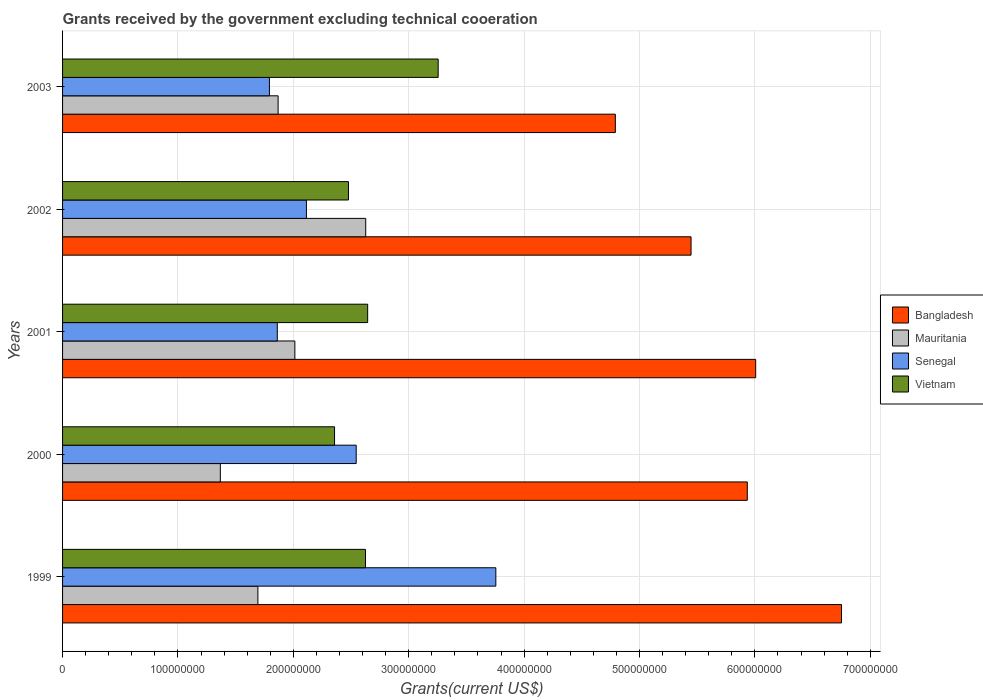How many different coloured bars are there?
Your answer should be compact. 4. How many groups of bars are there?
Give a very brief answer. 5. Are the number of bars per tick equal to the number of legend labels?
Your response must be concise. Yes. Are the number of bars on each tick of the Y-axis equal?
Your answer should be very brief. Yes. How many bars are there on the 4th tick from the top?
Your answer should be very brief. 4. What is the label of the 4th group of bars from the top?
Keep it short and to the point. 2000. In how many cases, is the number of bars for a given year not equal to the number of legend labels?
Give a very brief answer. 0. What is the total grants received by the government in Vietnam in 2002?
Your response must be concise. 2.48e+08. Across all years, what is the maximum total grants received by the government in Mauritania?
Keep it short and to the point. 2.63e+08. Across all years, what is the minimum total grants received by the government in Mauritania?
Your answer should be compact. 1.37e+08. In which year was the total grants received by the government in Senegal maximum?
Give a very brief answer. 1999. What is the total total grants received by the government in Bangladesh in the graph?
Make the answer very short. 2.89e+09. What is the difference between the total grants received by the government in Mauritania in 1999 and that in 2000?
Offer a terse response. 3.26e+07. What is the difference between the total grants received by the government in Mauritania in 2000 and the total grants received by the government in Bangladesh in 2001?
Your answer should be very brief. -4.64e+08. What is the average total grants received by the government in Vietnam per year?
Your response must be concise. 2.67e+08. In the year 2001, what is the difference between the total grants received by the government in Senegal and total grants received by the government in Bangladesh?
Provide a succinct answer. -4.15e+08. What is the ratio of the total grants received by the government in Vietnam in 2000 to that in 2003?
Make the answer very short. 0.72. Is the difference between the total grants received by the government in Senegal in 2000 and 2001 greater than the difference between the total grants received by the government in Bangladesh in 2000 and 2001?
Make the answer very short. Yes. What is the difference between the highest and the second highest total grants received by the government in Mauritania?
Make the answer very short. 6.14e+07. What is the difference between the highest and the lowest total grants received by the government in Bangladesh?
Give a very brief answer. 1.96e+08. Is it the case that in every year, the sum of the total grants received by the government in Mauritania and total grants received by the government in Bangladesh is greater than the sum of total grants received by the government in Senegal and total grants received by the government in Vietnam?
Offer a terse response. No. What does the 3rd bar from the top in 2000 represents?
Offer a very short reply. Mauritania. What does the 4th bar from the bottom in 2000 represents?
Provide a short and direct response. Vietnam. Is it the case that in every year, the sum of the total grants received by the government in Bangladesh and total grants received by the government in Vietnam is greater than the total grants received by the government in Mauritania?
Offer a terse response. Yes. Are all the bars in the graph horizontal?
Your answer should be compact. Yes. What is the difference between two consecutive major ticks on the X-axis?
Your response must be concise. 1.00e+08. Does the graph contain grids?
Offer a terse response. Yes. Where does the legend appear in the graph?
Offer a very short reply. Center right. What is the title of the graph?
Your answer should be compact. Grants received by the government excluding technical cooeration. What is the label or title of the X-axis?
Your answer should be very brief. Grants(current US$). What is the label or title of the Y-axis?
Your answer should be very brief. Years. What is the Grants(current US$) of Bangladesh in 1999?
Your answer should be compact. 6.75e+08. What is the Grants(current US$) of Mauritania in 1999?
Give a very brief answer. 1.69e+08. What is the Grants(current US$) of Senegal in 1999?
Ensure brevity in your answer.  3.76e+08. What is the Grants(current US$) in Vietnam in 1999?
Provide a short and direct response. 2.63e+08. What is the Grants(current US$) of Bangladesh in 2000?
Ensure brevity in your answer.  5.93e+08. What is the Grants(current US$) of Mauritania in 2000?
Offer a terse response. 1.37e+08. What is the Grants(current US$) in Senegal in 2000?
Your answer should be compact. 2.54e+08. What is the Grants(current US$) in Vietnam in 2000?
Make the answer very short. 2.36e+08. What is the Grants(current US$) in Bangladesh in 2001?
Your answer should be compact. 6.01e+08. What is the Grants(current US$) in Mauritania in 2001?
Give a very brief answer. 2.01e+08. What is the Grants(current US$) of Senegal in 2001?
Provide a succinct answer. 1.86e+08. What is the Grants(current US$) in Vietnam in 2001?
Your response must be concise. 2.64e+08. What is the Grants(current US$) in Bangladesh in 2002?
Your answer should be compact. 5.45e+08. What is the Grants(current US$) in Mauritania in 2002?
Make the answer very short. 2.63e+08. What is the Grants(current US$) in Senegal in 2002?
Your answer should be compact. 2.11e+08. What is the Grants(current US$) in Vietnam in 2002?
Offer a very short reply. 2.48e+08. What is the Grants(current US$) of Bangladesh in 2003?
Keep it short and to the point. 4.79e+08. What is the Grants(current US$) of Mauritania in 2003?
Provide a short and direct response. 1.87e+08. What is the Grants(current US$) in Senegal in 2003?
Make the answer very short. 1.79e+08. What is the Grants(current US$) of Vietnam in 2003?
Provide a short and direct response. 3.26e+08. Across all years, what is the maximum Grants(current US$) of Bangladesh?
Offer a terse response. 6.75e+08. Across all years, what is the maximum Grants(current US$) of Mauritania?
Ensure brevity in your answer.  2.63e+08. Across all years, what is the maximum Grants(current US$) of Senegal?
Provide a succinct answer. 3.76e+08. Across all years, what is the maximum Grants(current US$) in Vietnam?
Give a very brief answer. 3.26e+08. Across all years, what is the minimum Grants(current US$) of Bangladesh?
Keep it short and to the point. 4.79e+08. Across all years, what is the minimum Grants(current US$) in Mauritania?
Your response must be concise. 1.37e+08. Across all years, what is the minimum Grants(current US$) of Senegal?
Give a very brief answer. 1.79e+08. Across all years, what is the minimum Grants(current US$) in Vietnam?
Keep it short and to the point. 2.36e+08. What is the total Grants(current US$) in Bangladesh in the graph?
Give a very brief answer. 2.89e+09. What is the total Grants(current US$) in Mauritania in the graph?
Offer a very short reply. 9.57e+08. What is the total Grants(current US$) of Senegal in the graph?
Provide a succinct answer. 1.21e+09. What is the total Grants(current US$) of Vietnam in the graph?
Provide a succinct answer. 1.34e+09. What is the difference between the Grants(current US$) in Bangladesh in 1999 and that in 2000?
Provide a succinct answer. 8.17e+07. What is the difference between the Grants(current US$) of Mauritania in 1999 and that in 2000?
Ensure brevity in your answer.  3.26e+07. What is the difference between the Grants(current US$) of Senegal in 1999 and that in 2000?
Give a very brief answer. 1.21e+08. What is the difference between the Grants(current US$) of Vietnam in 1999 and that in 2000?
Offer a terse response. 2.68e+07. What is the difference between the Grants(current US$) of Bangladesh in 1999 and that in 2001?
Offer a terse response. 7.44e+07. What is the difference between the Grants(current US$) in Mauritania in 1999 and that in 2001?
Keep it short and to the point. -3.20e+07. What is the difference between the Grants(current US$) in Senegal in 1999 and that in 2001?
Offer a very short reply. 1.89e+08. What is the difference between the Grants(current US$) in Vietnam in 1999 and that in 2001?
Your response must be concise. -1.88e+06. What is the difference between the Grants(current US$) of Bangladesh in 1999 and that in 2002?
Make the answer very short. 1.30e+08. What is the difference between the Grants(current US$) in Mauritania in 1999 and that in 2002?
Your answer should be compact. -9.34e+07. What is the difference between the Grants(current US$) in Senegal in 1999 and that in 2002?
Give a very brief answer. 1.64e+08. What is the difference between the Grants(current US$) in Vietnam in 1999 and that in 2002?
Offer a very short reply. 1.48e+07. What is the difference between the Grants(current US$) of Bangladesh in 1999 and that in 2003?
Your answer should be very brief. 1.96e+08. What is the difference between the Grants(current US$) in Mauritania in 1999 and that in 2003?
Offer a terse response. -1.75e+07. What is the difference between the Grants(current US$) in Senegal in 1999 and that in 2003?
Your answer should be very brief. 1.96e+08. What is the difference between the Grants(current US$) in Vietnam in 1999 and that in 2003?
Provide a short and direct response. -6.30e+07. What is the difference between the Grants(current US$) in Bangladesh in 2000 and that in 2001?
Your answer should be compact. -7.28e+06. What is the difference between the Grants(current US$) in Mauritania in 2000 and that in 2001?
Your response must be concise. -6.46e+07. What is the difference between the Grants(current US$) of Senegal in 2000 and that in 2001?
Your answer should be very brief. 6.84e+07. What is the difference between the Grants(current US$) of Vietnam in 2000 and that in 2001?
Offer a very short reply. -2.87e+07. What is the difference between the Grants(current US$) in Bangladesh in 2000 and that in 2002?
Your response must be concise. 4.88e+07. What is the difference between the Grants(current US$) in Mauritania in 2000 and that in 2002?
Give a very brief answer. -1.26e+08. What is the difference between the Grants(current US$) in Senegal in 2000 and that in 2002?
Your answer should be compact. 4.31e+07. What is the difference between the Grants(current US$) of Vietnam in 2000 and that in 2002?
Ensure brevity in your answer.  -1.21e+07. What is the difference between the Grants(current US$) of Bangladesh in 2000 and that in 2003?
Ensure brevity in your answer.  1.14e+08. What is the difference between the Grants(current US$) of Mauritania in 2000 and that in 2003?
Your answer should be very brief. -5.01e+07. What is the difference between the Grants(current US$) in Senegal in 2000 and that in 2003?
Your response must be concise. 7.52e+07. What is the difference between the Grants(current US$) in Vietnam in 2000 and that in 2003?
Your answer should be compact. -8.98e+07. What is the difference between the Grants(current US$) in Bangladesh in 2001 and that in 2002?
Make the answer very short. 5.60e+07. What is the difference between the Grants(current US$) in Mauritania in 2001 and that in 2002?
Your response must be concise. -6.14e+07. What is the difference between the Grants(current US$) in Senegal in 2001 and that in 2002?
Offer a terse response. -2.52e+07. What is the difference between the Grants(current US$) in Vietnam in 2001 and that in 2002?
Ensure brevity in your answer.  1.66e+07. What is the difference between the Grants(current US$) of Bangladesh in 2001 and that in 2003?
Make the answer very short. 1.22e+08. What is the difference between the Grants(current US$) in Mauritania in 2001 and that in 2003?
Your answer should be very brief. 1.45e+07. What is the difference between the Grants(current US$) of Senegal in 2001 and that in 2003?
Provide a succinct answer. 6.82e+06. What is the difference between the Grants(current US$) of Vietnam in 2001 and that in 2003?
Your answer should be very brief. -6.11e+07. What is the difference between the Grants(current US$) in Bangladesh in 2002 and that in 2003?
Your response must be concise. 6.56e+07. What is the difference between the Grants(current US$) of Mauritania in 2002 and that in 2003?
Your answer should be compact. 7.59e+07. What is the difference between the Grants(current US$) in Senegal in 2002 and that in 2003?
Give a very brief answer. 3.21e+07. What is the difference between the Grants(current US$) of Vietnam in 2002 and that in 2003?
Keep it short and to the point. -7.77e+07. What is the difference between the Grants(current US$) of Bangladesh in 1999 and the Grants(current US$) of Mauritania in 2000?
Keep it short and to the point. 5.38e+08. What is the difference between the Grants(current US$) of Bangladesh in 1999 and the Grants(current US$) of Senegal in 2000?
Your answer should be compact. 4.21e+08. What is the difference between the Grants(current US$) of Bangladesh in 1999 and the Grants(current US$) of Vietnam in 2000?
Your response must be concise. 4.39e+08. What is the difference between the Grants(current US$) in Mauritania in 1999 and the Grants(current US$) in Senegal in 2000?
Your answer should be very brief. -8.52e+07. What is the difference between the Grants(current US$) in Mauritania in 1999 and the Grants(current US$) in Vietnam in 2000?
Your response must be concise. -6.64e+07. What is the difference between the Grants(current US$) in Senegal in 1999 and the Grants(current US$) in Vietnam in 2000?
Offer a terse response. 1.40e+08. What is the difference between the Grants(current US$) of Bangladesh in 1999 and the Grants(current US$) of Mauritania in 2001?
Offer a terse response. 4.74e+08. What is the difference between the Grants(current US$) of Bangladesh in 1999 and the Grants(current US$) of Senegal in 2001?
Your answer should be compact. 4.89e+08. What is the difference between the Grants(current US$) of Bangladesh in 1999 and the Grants(current US$) of Vietnam in 2001?
Provide a succinct answer. 4.11e+08. What is the difference between the Grants(current US$) in Mauritania in 1999 and the Grants(current US$) in Senegal in 2001?
Ensure brevity in your answer.  -1.68e+07. What is the difference between the Grants(current US$) of Mauritania in 1999 and the Grants(current US$) of Vietnam in 2001?
Make the answer very short. -9.51e+07. What is the difference between the Grants(current US$) of Senegal in 1999 and the Grants(current US$) of Vietnam in 2001?
Keep it short and to the point. 1.11e+08. What is the difference between the Grants(current US$) in Bangladesh in 1999 and the Grants(current US$) in Mauritania in 2002?
Provide a short and direct response. 4.12e+08. What is the difference between the Grants(current US$) in Bangladesh in 1999 and the Grants(current US$) in Senegal in 2002?
Offer a terse response. 4.64e+08. What is the difference between the Grants(current US$) in Bangladesh in 1999 and the Grants(current US$) in Vietnam in 2002?
Provide a succinct answer. 4.27e+08. What is the difference between the Grants(current US$) of Mauritania in 1999 and the Grants(current US$) of Senegal in 2002?
Your answer should be very brief. -4.21e+07. What is the difference between the Grants(current US$) of Mauritania in 1999 and the Grants(current US$) of Vietnam in 2002?
Give a very brief answer. -7.85e+07. What is the difference between the Grants(current US$) in Senegal in 1999 and the Grants(current US$) in Vietnam in 2002?
Your answer should be compact. 1.28e+08. What is the difference between the Grants(current US$) of Bangladesh in 1999 and the Grants(current US$) of Mauritania in 2003?
Give a very brief answer. 4.88e+08. What is the difference between the Grants(current US$) in Bangladesh in 1999 and the Grants(current US$) in Senegal in 2003?
Make the answer very short. 4.96e+08. What is the difference between the Grants(current US$) in Bangladesh in 1999 and the Grants(current US$) in Vietnam in 2003?
Give a very brief answer. 3.50e+08. What is the difference between the Grants(current US$) of Mauritania in 1999 and the Grants(current US$) of Senegal in 2003?
Provide a short and direct response. -1.00e+07. What is the difference between the Grants(current US$) in Mauritania in 1999 and the Grants(current US$) in Vietnam in 2003?
Keep it short and to the point. -1.56e+08. What is the difference between the Grants(current US$) of Senegal in 1999 and the Grants(current US$) of Vietnam in 2003?
Ensure brevity in your answer.  5.00e+07. What is the difference between the Grants(current US$) in Bangladesh in 2000 and the Grants(current US$) in Mauritania in 2001?
Your response must be concise. 3.92e+08. What is the difference between the Grants(current US$) of Bangladesh in 2000 and the Grants(current US$) of Senegal in 2001?
Your answer should be very brief. 4.07e+08. What is the difference between the Grants(current US$) of Bangladesh in 2000 and the Grants(current US$) of Vietnam in 2001?
Ensure brevity in your answer.  3.29e+08. What is the difference between the Grants(current US$) of Mauritania in 2000 and the Grants(current US$) of Senegal in 2001?
Give a very brief answer. -4.94e+07. What is the difference between the Grants(current US$) of Mauritania in 2000 and the Grants(current US$) of Vietnam in 2001?
Your answer should be compact. -1.28e+08. What is the difference between the Grants(current US$) in Senegal in 2000 and the Grants(current US$) in Vietnam in 2001?
Your response must be concise. -9.93e+06. What is the difference between the Grants(current US$) in Bangladesh in 2000 and the Grants(current US$) in Mauritania in 2002?
Make the answer very short. 3.31e+08. What is the difference between the Grants(current US$) of Bangladesh in 2000 and the Grants(current US$) of Senegal in 2002?
Keep it short and to the point. 3.82e+08. What is the difference between the Grants(current US$) in Bangladesh in 2000 and the Grants(current US$) in Vietnam in 2002?
Your answer should be very brief. 3.46e+08. What is the difference between the Grants(current US$) of Mauritania in 2000 and the Grants(current US$) of Senegal in 2002?
Your response must be concise. -7.46e+07. What is the difference between the Grants(current US$) in Mauritania in 2000 and the Grants(current US$) in Vietnam in 2002?
Keep it short and to the point. -1.11e+08. What is the difference between the Grants(current US$) in Senegal in 2000 and the Grants(current US$) in Vietnam in 2002?
Offer a very short reply. 6.70e+06. What is the difference between the Grants(current US$) in Bangladesh in 2000 and the Grants(current US$) in Mauritania in 2003?
Make the answer very short. 4.07e+08. What is the difference between the Grants(current US$) in Bangladesh in 2000 and the Grants(current US$) in Senegal in 2003?
Offer a very short reply. 4.14e+08. What is the difference between the Grants(current US$) in Bangladesh in 2000 and the Grants(current US$) in Vietnam in 2003?
Make the answer very short. 2.68e+08. What is the difference between the Grants(current US$) in Mauritania in 2000 and the Grants(current US$) in Senegal in 2003?
Your answer should be compact. -4.26e+07. What is the difference between the Grants(current US$) of Mauritania in 2000 and the Grants(current US$) of Vietnam in 2003?
Your answer should be compact. -1.89e+08. What is the difference between the Grants(current US$) in Senegal in 2000 and the Grants(current US$) in Vietnam in 2003?
Your response must be concise. -7.10e+07. What is the difference between the Grants(current US$) of Bangladesh in 2001 and the Grants(current US$) of Mauritania in 2002?
Your answer should be compact. 3.38e+08. What is the difference between the Grants(current US$) of Bangladesh in 2001 and the Grants(current US$) of Senegal in 2002?
Your response must be concise. 3.89e+08. What is the difference between the Grants(current US$) in Bangladesh in 2001 and the Grants(current US$) in Vietnam in 2002?
Your answer should be very brief. 3.53e+08. What is the difference between the Grants(current US$) in Mauritania in 2001 and the Grants(current US$) in Senegal in 2002?
Your response must be concise. -1.00e+07. What is the difference between the Grants(current US$) in Mauritania in 2001 and the Grants(current US$) in Vietnam in 2002?
Offer a terse response. -4.65e+07. What is the difference between the Grants(current US$) of Senegal in 2001 and the Grants(current US$) of Vietnam in 2002?
Give a very brief answer. -6.17e+07. What is the difference between the Grants(current US$) in Bangladesh in 2001 and the Grants(current US$) in Mauritania in 2003?
Your response must be concise. 4.14e+08. What is the difference between the Grants(current US$) in Bangladesh in 2001 and the Grants(current US$) in Senegal in 2003?
Offer a very short reply. 4.21e+08. What is the difference between the Grants(current US$) in Bangladesh in 2001 and the Grants(current US$) in Vietnam in 2003?
Keep it short and to the point. 2.75e+08. What is the difference between the Grants(current US$) in Mauritania in 2001 and the Grants(current US$) in Senegal in 2003?
Make the answer very short. 2.20e+07. What is the difference between the Grants(current US$) of Mauritania in 2001 and the Grants(current US$) of Vietnam in 2003?
Give a very brief answer. -1.24e+08. What is the difference between the Grants(current US$) of Senegal in 2001 and the Grants(current US$) of Vietnam in 2003?
Give a very brief answer. -1.39e+08. What is the difference between the Grants(current US$) in Bangladesh in 2002 and the Grants(current US$) in Mauritania in 2003?
Your answer should be very brief. 3.58e+08. What is the difference between the Grants(current US$) in Bangladesh in 2002 and the Grants(current US$) in Senegal in 2003?
Provide a short and direct response. 3.65e+08. What is the difference between the Grants(current US$) in Bangladesh in 2002 and the Grants(current US$) in Vietnam in 2003?
Provide a short and direct response. 2.19e+08. What is the difference between the Grants(current US$) of Mauritania in 2002 and the Grants(current US$) of Senegal in 2003?
Offer a terse response. 8.34e+07. What is the difference between the Grants(current US$) in Mauritania in 2002 and the Grants(current US$) in Vietnam in 2003?
Your answer should be very brief. -6.28e+07. What is the difference between the Grants(current US$) of Senegal in 2002 and the Grants(current US$) of Vietnam in 2003?
Ensure brevity in your answer.  -1.14e+08. What is the average Grants(current US$) of Bangladesh per year?
Provide a short and direct response. 5.79e+08. What is the average Grants(current US$) in Mauritania per year?
Provide a short and direct response. 1.91e+08. What is the average Grants(current US$) in Senegal per year?
Provide a succinct answer. 2.41e+08. What is the average Grants(current US$) in Vietnam per year?
Keep it short and to the point. 2.67e+08. In the year 1999, what is the difference between the Grants(current US$) in Bangladesh and Grants(current US$) in Mauritania?
Offer a very short reply. 5.06e+08. In the year 1999, what is the difference between the Grants(current US$) in Bangladesh and Grants(current US$) in Senegal?
Your answer should be very brief. 3.00e+08. In the year 1999, what is the difference between the Grants(current US$) of Bangladesh and Grants(current US$) of Vietnam?
Provide a succinct answer. 4.13e+08. In the year 1999, what is the difference between the Grants(current US$) of Mauritania and Grants(current US$) of Senegal?
Keep it short and to the point. -2.06e+08. In the year 1999, what is the difference between the Grants(current US$) of Mauritania and Grants(current US$) of Vietnam?
Give a very brief answer. -9.32e+07. In the year 1999, what is the difference between the Grants(current US$) in Senegal and Grants(current US$) in Vietnam?
Offer a terse response. 1.13e+08. In the year 2000, what is the difference between the Grants(current US$) in Bangladesh and Grants(current US$) in Mauritania?
Your response must be concise. 4.57e+08. In the year 2000, what is the difference between the Grants(current US$) in Bangladesh and Grants(current US$) in Senegal?
Give a very brief answer. 3.39e+08. In the year 2000, what is the difference between the Grants(current US$) of Bangladesh and Grants(current US$) of Vietnam?
Provide a short and direct response. 3.58e+08. In the year 2000, what is the difference between the Grants(current US$) of Mauritania and Grants(current US$) of Senegal?
Your answer should be very brief. -1.18e+08. In the year 2000, what is the difference between the Grants(current US$) in Mauritania and Grants(current US$) in Vietnam?
Your answer should be very brief. -9.90e+07. In the year 2000, what is the difference between the Grants(current US$) of Senegal and Grants(current US$) of Vietnam?
Ensure brevity in your answer.  1.88e+07. In the year 2001, what is the difference between the Grants(current US$) of Bangladesh and Grants(current US$) of Mauritania?
Provide a succinct answer. 3.99e+08. In the year 2001, what is the difference between the Grants(current US$) of Bangladesh and Grants(current US$) of Senegal?
Keep it short and to the point. 4.15e+08. In the year 2001, what is the difference between the Grants(current US$) in Bangladesh and Grants(current US$) in Vietnam?
Ensure brevity in your answer.  3.36e+08. In the year 2001, what is the difference between the Grants(current US$) of Mauritania and Grants(current US$) of Senegal?
Ensure brevity in your answer.  1.52e+07. In the year 2001, what is the difference between the Grants(current US$) in Mauritania and Grants(current US$) in Vietnam?
Keep it short and to the point. -6.31e+07. In the year 2001, what is the difference between the Grants(current US$) of Senegal and Grants(current US$) of Vietnam?
Keep it short and to the point. -7.83e+07. In the year 2002, what is the difference between the Grants(current US$) of Bangladesh and Grants(current US$) of Mauritania?
Your answer should be compact. 2.82e+08. In the year 2002, what is the difference between the Grants(current US$) of Bangladesh and Grants(current US$) of Senegal?
Keep it short and to the point. 3.33e+08. In the year 2002, what is the difference between the Grants(current US$) of Bangladesh and Grants(current US$) of Vietnam?
Provide a succinct answer. 2.97e+08. In the year 2002, what is the difference between the Grants(current US$) in Mauritania and Grants(current US$) in Senegal?
Ensure brevity in your answer.  5.14e+07. In the year 2002, what is the difference between the Grants(current US$) of Mauritania and Grants(current US$) of Vietnam?
Offer a very short reply. 1.50e+07. In the year 2002, what is the difference between the Grants(current US$) of Senegal and Grants(current US$) of Vietnam?
Ensure brevity in your answer.  -3.64e+07. In the year 2003, what is the difference between the Grants(current US$) of Bangladesh and Grants(current US$) of Mauritania?
Provide a succinct answer. 2.92e+08. In the year 2003, what is the difference between the Grants(current US$) in Bangladesh and Grants(current US$) in Senegal?
Provide a short and direct response. 3.00e+08. In the year 2003, what is the difference between the Grants(current US$) of Bangladesh and Grants(current US$) of Vietnam?
Offer a very short reply. 1.54e+08. In the year 2003, what is the difference between the Grants(current US$) of Mauritania and Grants(current US$) of Senegal?
Make the answer very short. 7.52e+06. In the year 2003, what is the difference between the Grants(current US$) of Mauritania and Grants(current US$) of Vietnam?
Offer a terse response. -1.39e+08. In the year 2003, what is the difference between the Grants(current US$) of Senegal and Grants(current US$) of Vietnam?
Keep it short and to the point. -1.46e+08. What is the ratio of the Grants(current US$) in Bangladesh in 1999 to that in 2000?
Provide a succinct answer. 1.14. What is the ratio of the Grants(current US$) in Mauritania in 1999 to that in 2000?
Keep it short and to the point. 1.24. What is the ratio of the Grants(current US$) in Senegal in 1999 to that in 2000?
Make the answer very short. 1.48. What is the ratio of the Grants(current US$) in Vietnam in 1999 to that in 2000?
Provide a short and direct response. 1.11. What is the ratio of the Grants(current US$) in Bangladesh in 1999 to that in 2001?
Make the answer very short. 1.12. What is the ratio of the Grants(current US$) in Mauritania in 1999 to that in 2001?
Ensure brevity in your answer.  0.84. What is the ratio of the Grants(current US$) in Senegal in 1999 to that in 2001?
Provide a short and direct response. 2.02. What is the ratio of the Grants(current US$) of Vietnam in 1999 to that in 2001?
Make the answer very short. 0.99. What is the ratio of the Grants(current US$) in Bangladesh in 1999 to that in 2002?
Offer a very short reply. 1.24. What is the ratio of the Grants(current US$) of Mauritania in 1999 to that in 2002?
Make the answer very short. 0.64. What is the ratio of the Grants(current US$) of Senegal in 1999 to that in 2002?
Your answer should be compact. 1.78. What is the ratio of the Grants(current US$) in Vietnam in 1999 to that in 2002?
Ensure brevity in your answer.  1.06. What is the ratio of the Grants(current US$) of Bangladesh in 1999 to that in 2003?
Make the answer very short. 1.41. What is the ratio of the Grants(current US$) of Mauritania in 1999 to that in 2003?
Make the answer very short. 0.91. What is the ratio of the Grants(current US$) of Senegal in 1999 to that in 2003?
Your response must be concise. 2.09. What is the ratio of the Grants(current US$) of Vietnam in 1999 to that in 2003?
Your answer should be compact. 0.81. What is the ratio of the Grants(current US$) in Bangladesh in 2000 to that in 2001?
Provide a succinct answer. 0.99. What is the ratio of the Grants(current US$) of Mauritania in 2000 to that in 2001?
Make the answer very short. 0.68. What is the ratio of the Grants(current US$) of Senegal in 2000 to that in 2001?
Your response must be concise. 1.37. What is the ratio of the Grants(current US$) in Vietnam in 2000 to that in 2001?
Your answer should be compact. 0.89. What is the ratio of the Grants(current US$) in Bangladesh in 2000 to that in 2002?
Make the answer very short. 1.09. What is the ratio of the Grants(current US$) in Mauritania in 2000 to that in 2002?
Your response must be concise. 0.52. What is the ratio of the Grants(current US$) in Senegal in 2000 to that in 2002?
Give a very brief answer. 1.2. What is the ratio of the Grants(current US$) of Vietnam in 2000 to that in 2002?
Keep it short and to the point. 0.95. What is the ratio of the Grants(current US$) of Bangladesh in 2000 to that in 2003?
Your answer should be compact. 1.24. What is the ratio of the Grants(current US$) of Mauritania in 2000 to that in 2003?
Offer a very short reply. 0.73. What is the ratio of the Grants(current US$) of Senegal in 2000 to that in 2003?
Keep it short and to the point. 1.42. What is the ratio of the Grants(current US$) in Vietnam in 2000 to that in 2003?
Offer a terse response. 0.72. What is the ratio of the Grants(current US$) of Bangladesh in 2001 to that in 2002?
Keep it short and to the point. 1.1. What is the ratio of the Grants(current US$) of Mauritania in 2001 to that in 2002?
Your response must be concise. 0.77. What is the ratio of the Grants(current US$) in Senegal in 2001 to that in 2002?
Offer a terse response. 0.88. What is the ratio of the Grants(current US$) in Vietnam in 2001 to that in 2002?
Ensure brevity in your answer.  1.07. What is the ratio of the Grants(current US$) in Bangladesh in 2001 to that in 2003?
Ensure brevity in your answer.  1.25. What is the ratio of the Grants(current US$) of Mauritania in 2001 to that in 2003?
Offer a very short reply. 1.08. What is the ratio of the Grants(current US$) of Senegal in 2001 to that in 2003?
Your answer should be compact. 1.04. What is the ratio of the Grants(current US$) in Vietnam in 2001 to that in 2003?
Provide a short and direct response. 0.81. What is the ratio of the Grants(current US$) of Bangladesh in 2002 to that in 2003?
Your answer should be very brief. 1.14. What is the ratio of the Grants(current US$) in Mauritania in 2002 to that in 2003?
Provide a short and direct response. 1.41. What is the ratio of the Grants(current US$) of Senegal in 2002 to that in 2003?
Provide a succinct answer. 1.18. What is the ratio of the Grants(current US$) of Vietnam in 2002 to that in 2003?
Provide a short and direct response. 0.76. What is the difference between the highest and the second highest Grants(current US$) in Bangladesh?
Offer a terse response. 7.44e+07. What is the difference between the highest and the second highest Grants(current US$) of Mauritania?
Your answer should be very brief. 6.14e+07. What is the difference between the highest and the second highest Grants(current US$) of Senegal?
Provide a succinct answer. 1.21e+08. What is the difference between the highest and the second highest Grants(current US$) of Vietnam?
Your response must be concise. 6.11e+07. What is the difference between the highest and the lowest Grants(current US$) of Bangladesh?
Give a very brief answer. 1.96e+08. What is the difference between the highest and the lowest Grants(current US$) of Mauritania?
Keep it short and to the point. 1.26e+08. What is the difference between the highest and the lowest Grants(current US$) in Senegal?
Keep it short and to the point. 1.96e+08. What is the difference between the highest and the lowest Grants(current US$) in Vietnam?
Keep it short and to the point. 8.98e+07. 